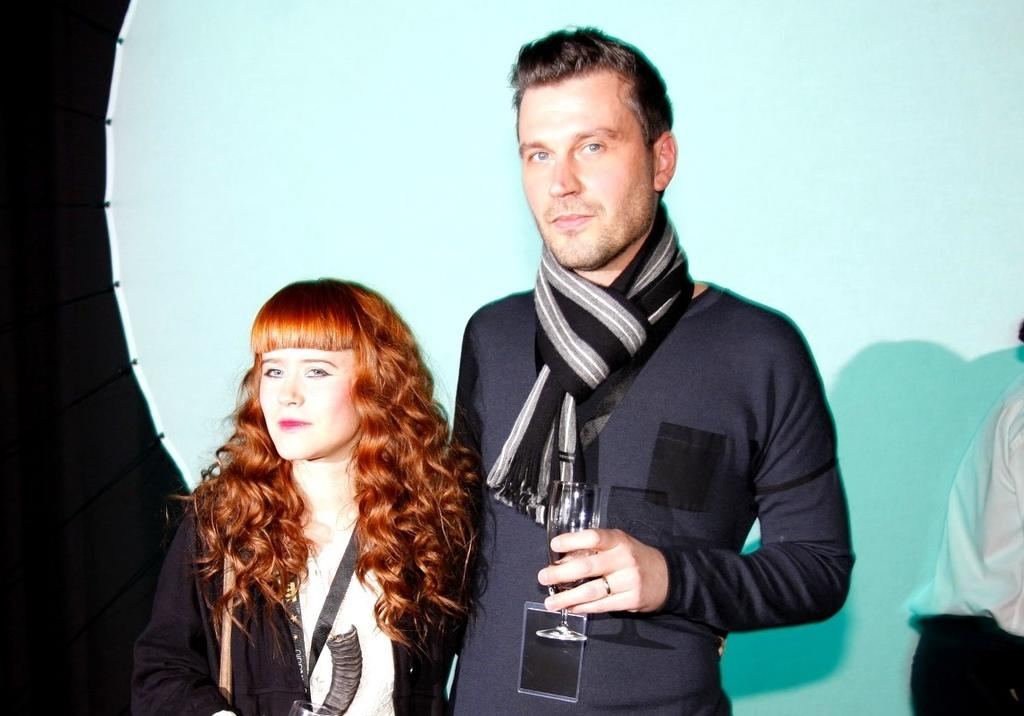Who are the people in the image? There is a man and a woman in the image. What are the man and the woman holding? Both the man and the woman are holding glasses. Can you describe the man's attire? The man is wearing a scarf. Is there anyone else visible in the image? Yes, there is another person in the background of the image. How many pigs can be seen in the image? There are no pigs present in the image. Who is the owner of the glasses in the image? The image does not provide information about the ownership of the glasses. 